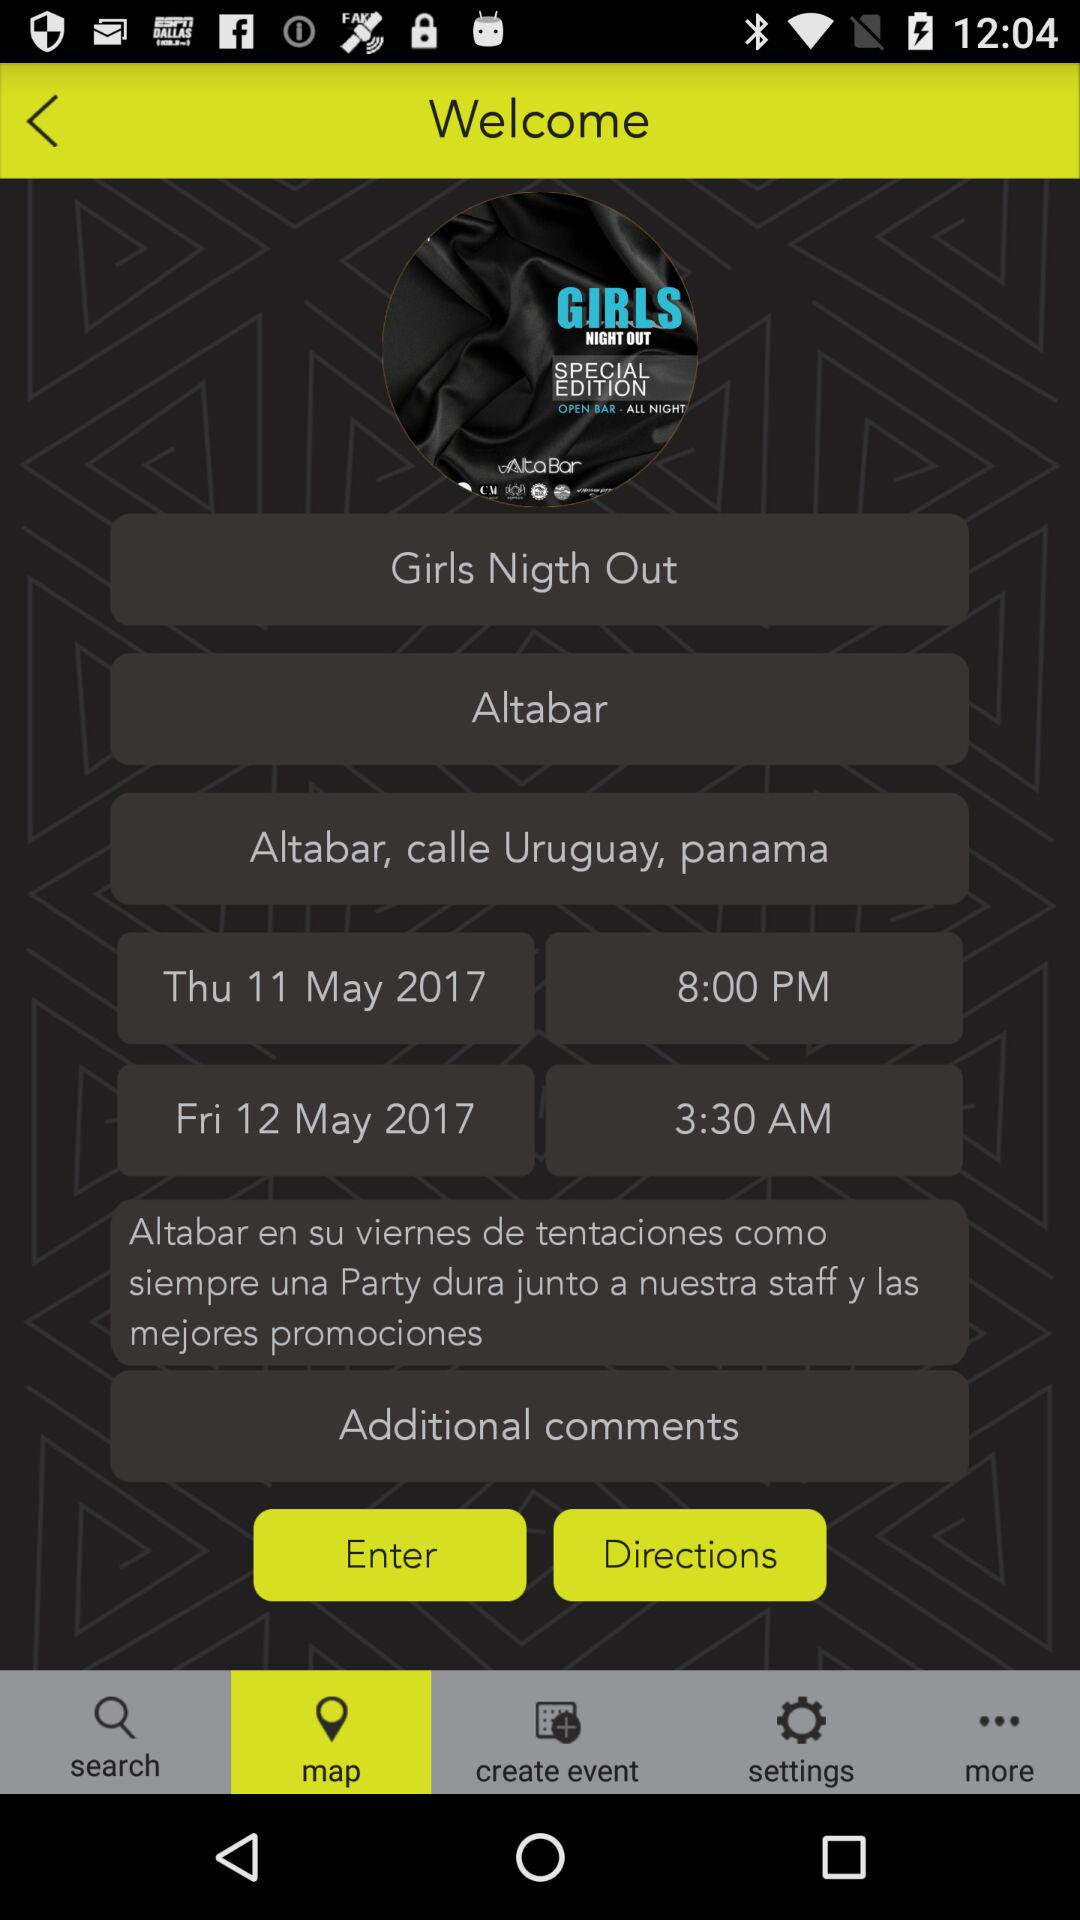What option has been selected? The selected option is "map". 